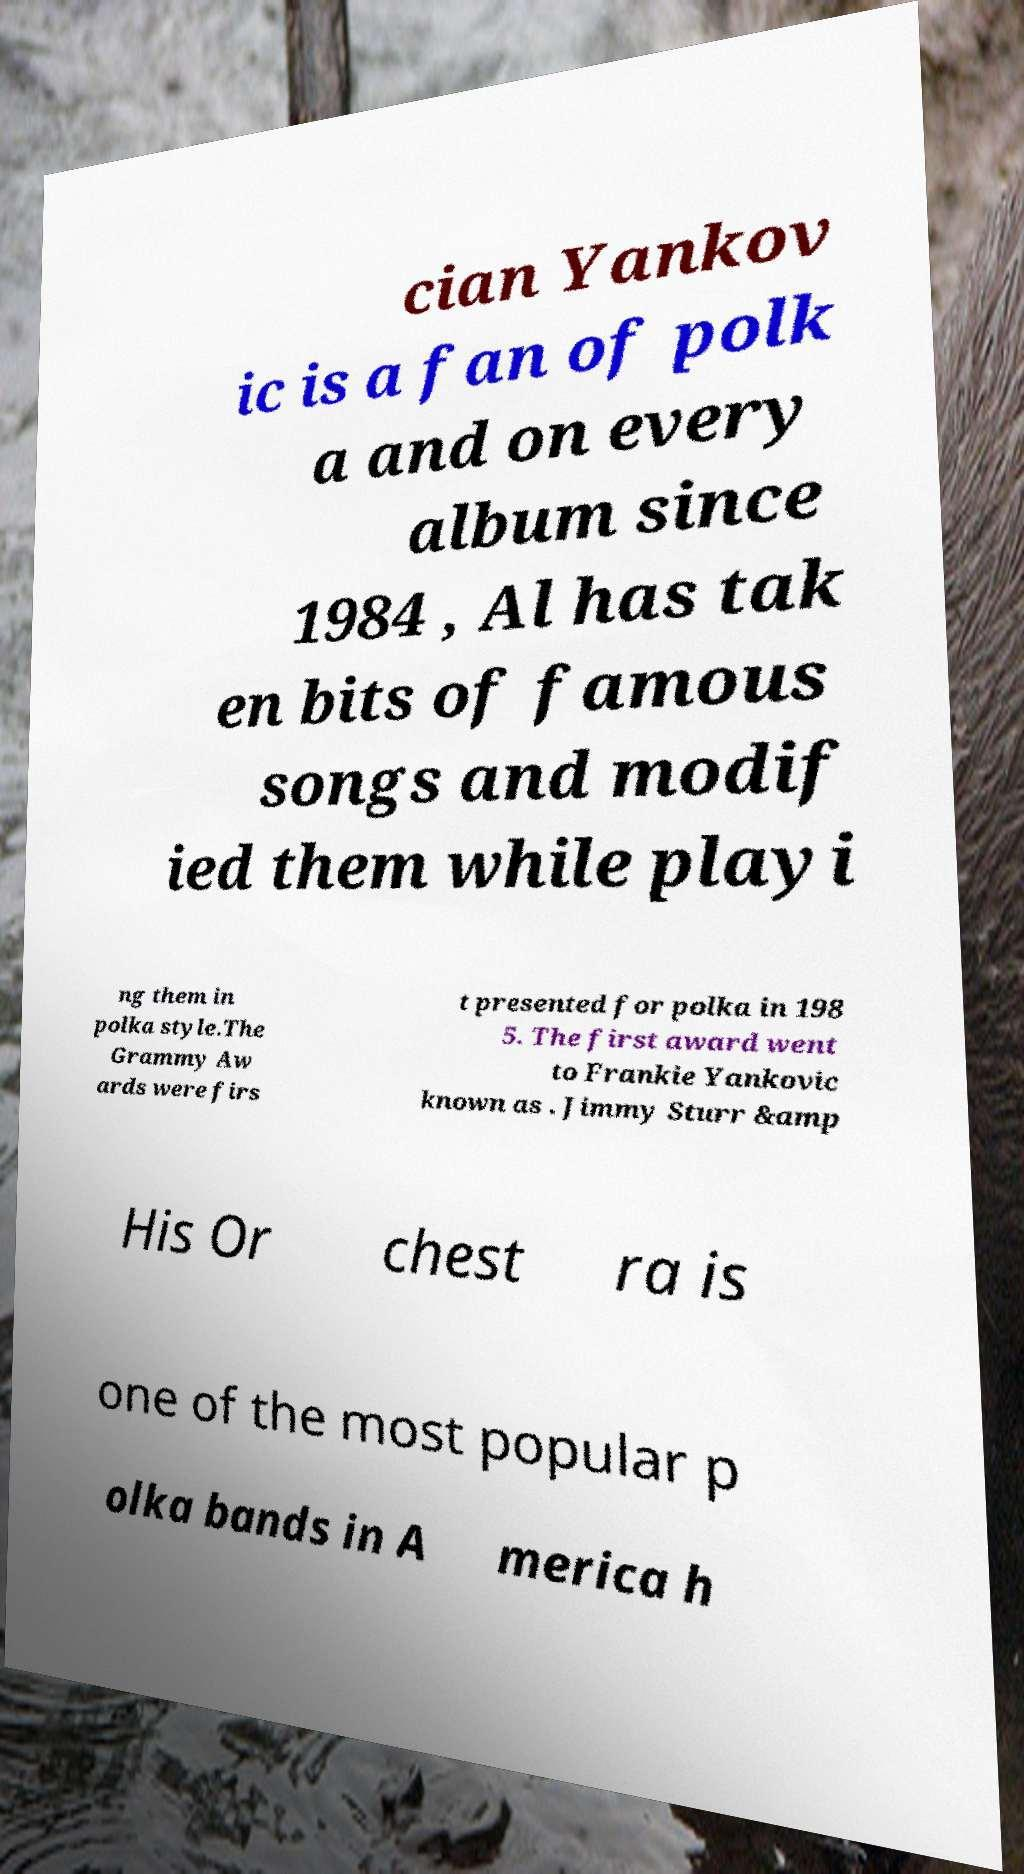Can you read and provide the text displayed in the image?This photo seems to have some interesting text. Can you extract and type it out for me? cian Yankov ic is a fan of polk a and on every album since 1984 , Al has tak en bits of famous songs and modif ied them while playi ng them in polka style.The Grammy Aw ards were firs t presented for polka in 198 5. The first award went to Frankie Yankovic known as . Jimmy Sturr &amp His Or chest ra is one of the most popular p olka bands in A merica h 